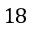<formula> <loc_0><loc_0><loc_500><loc_500>1 8</formula> 